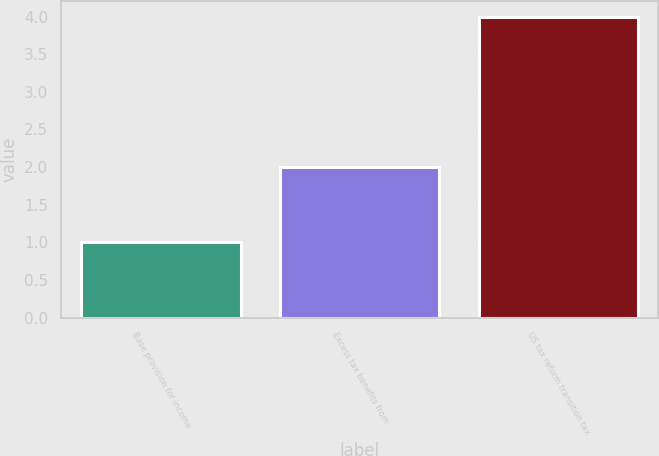<chart> <loc_0><loc_0><loc_500><loc_500><bar_chart><fcel>Base provision for income<fcel>Excess tax benefits from<fcel>US tax reform transition tax<nl><fcel>1<fcel>2<fcel>4<nl></chart> 